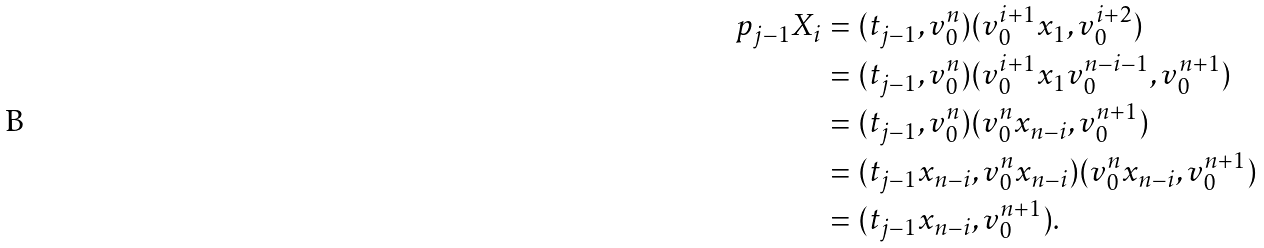<formula> <loc_0><loc_0><loc_500><loc_500>p _ { j - 1 } X _ { i } & = ( t _ { j - 1 } , v _ { 0 } ^ { n } ) ( v _ { 0 } ^ { i + 1 } x _ { 1 } , v _ { 0 } ^ { i + 2 } ) \\ & = ( t _ { j - 1 } , v _ { 0 } ^ { n } ) ( v _ { 0 } ^ { i + 1 } x _ { 1 } v _ { 0 } ^ { n - i - 1 } , v _ { 0 } ^ { n + 1 } ) \\ & = ( t _ { j - 1 } , v _ { 0 } ^ { n } ) ( v _ { 0 } ^ { n } x _ { n - i } , v _ { 0 } ^ { n + 1 } ) \\ & = ( t _ { j - 1 } x _ { n - i } , v _ { 0 } ^ { n } x _ { n - i } ) ( v _ { 0 } ^ { n } x _ { n - i } , v _ { 0 } ^ { n + 1 } ) \\ & = ( t _ { j - 1 } x _ { n - i } , v _ { 0 } ^ { n + 1 } ) .</formula> 